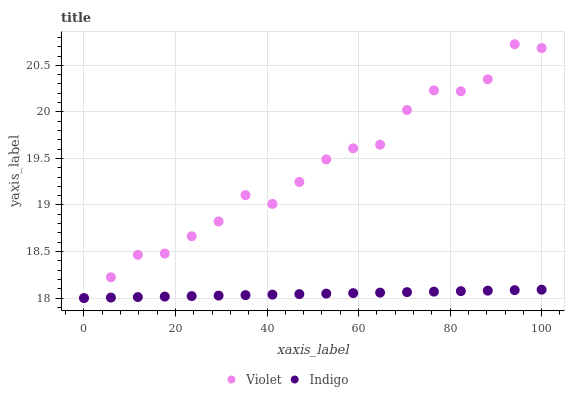Does Indigo have the minimum area under the curve?
Answer yes or no. Yes. Does Violet have the maximum area under the curve?
Answer yes or no. Yes. Does Violet have the minimum area under the curve?
Answer yes or no. No. Is Indigo the smoothest?
Answer yes or no. Yes. Is Violet the roughest?
Answer yes or no. Yes. Is Violet the smoothest?
Answer yes or no. No. Does Indigo have the lowest value?
Answer yes or no. Yes. Does Violet have the highest value?
Answer yes or no. Yes. Does Violet intersect Indigo?
Answer yes or no. Yes. Is Violet less than Indigo?
Answer yes or no. No. Is Violet greater than Indigo?
Answer yes or no. No. 